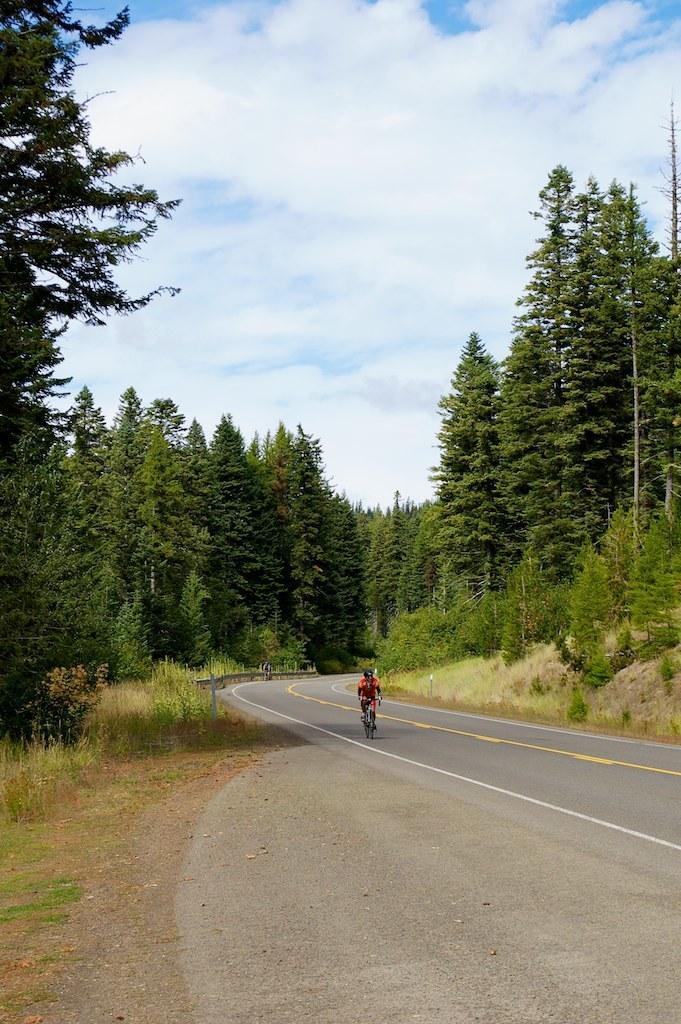Describe this image in one or two sentences. In this picture there is a person riding bicycle on the road and we can see grass, plants and trees. In the background of the image we can see sky with clouds. 